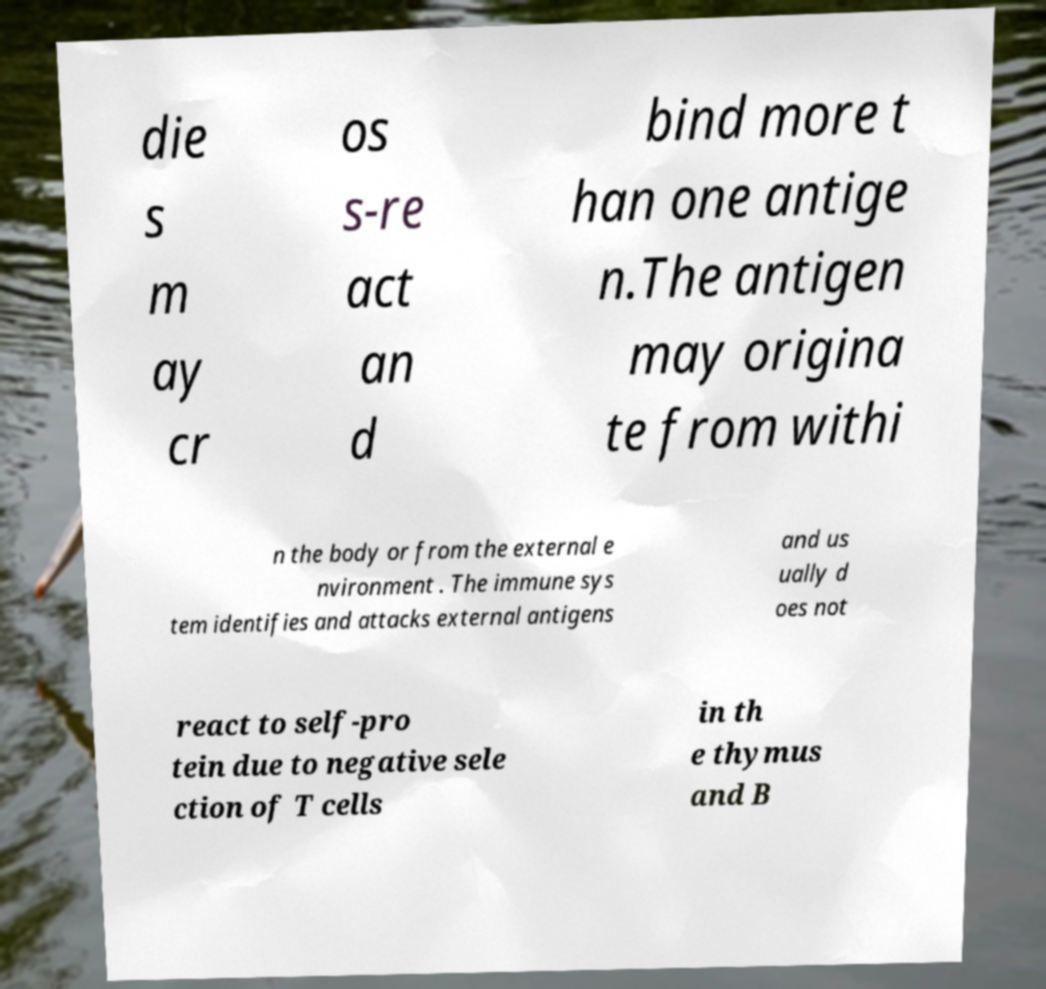Please identify and transcribe the text found in this image. die s m ay cr os s-re act an d bind more t han one antige n.The antigen may origina te from withi n the body or from the external e nvironment . The immune sys tem identifies and attacks external antigens and us ually d oes not react to self-pro tein due to negative sele ction of T cells in th e thymus and B 